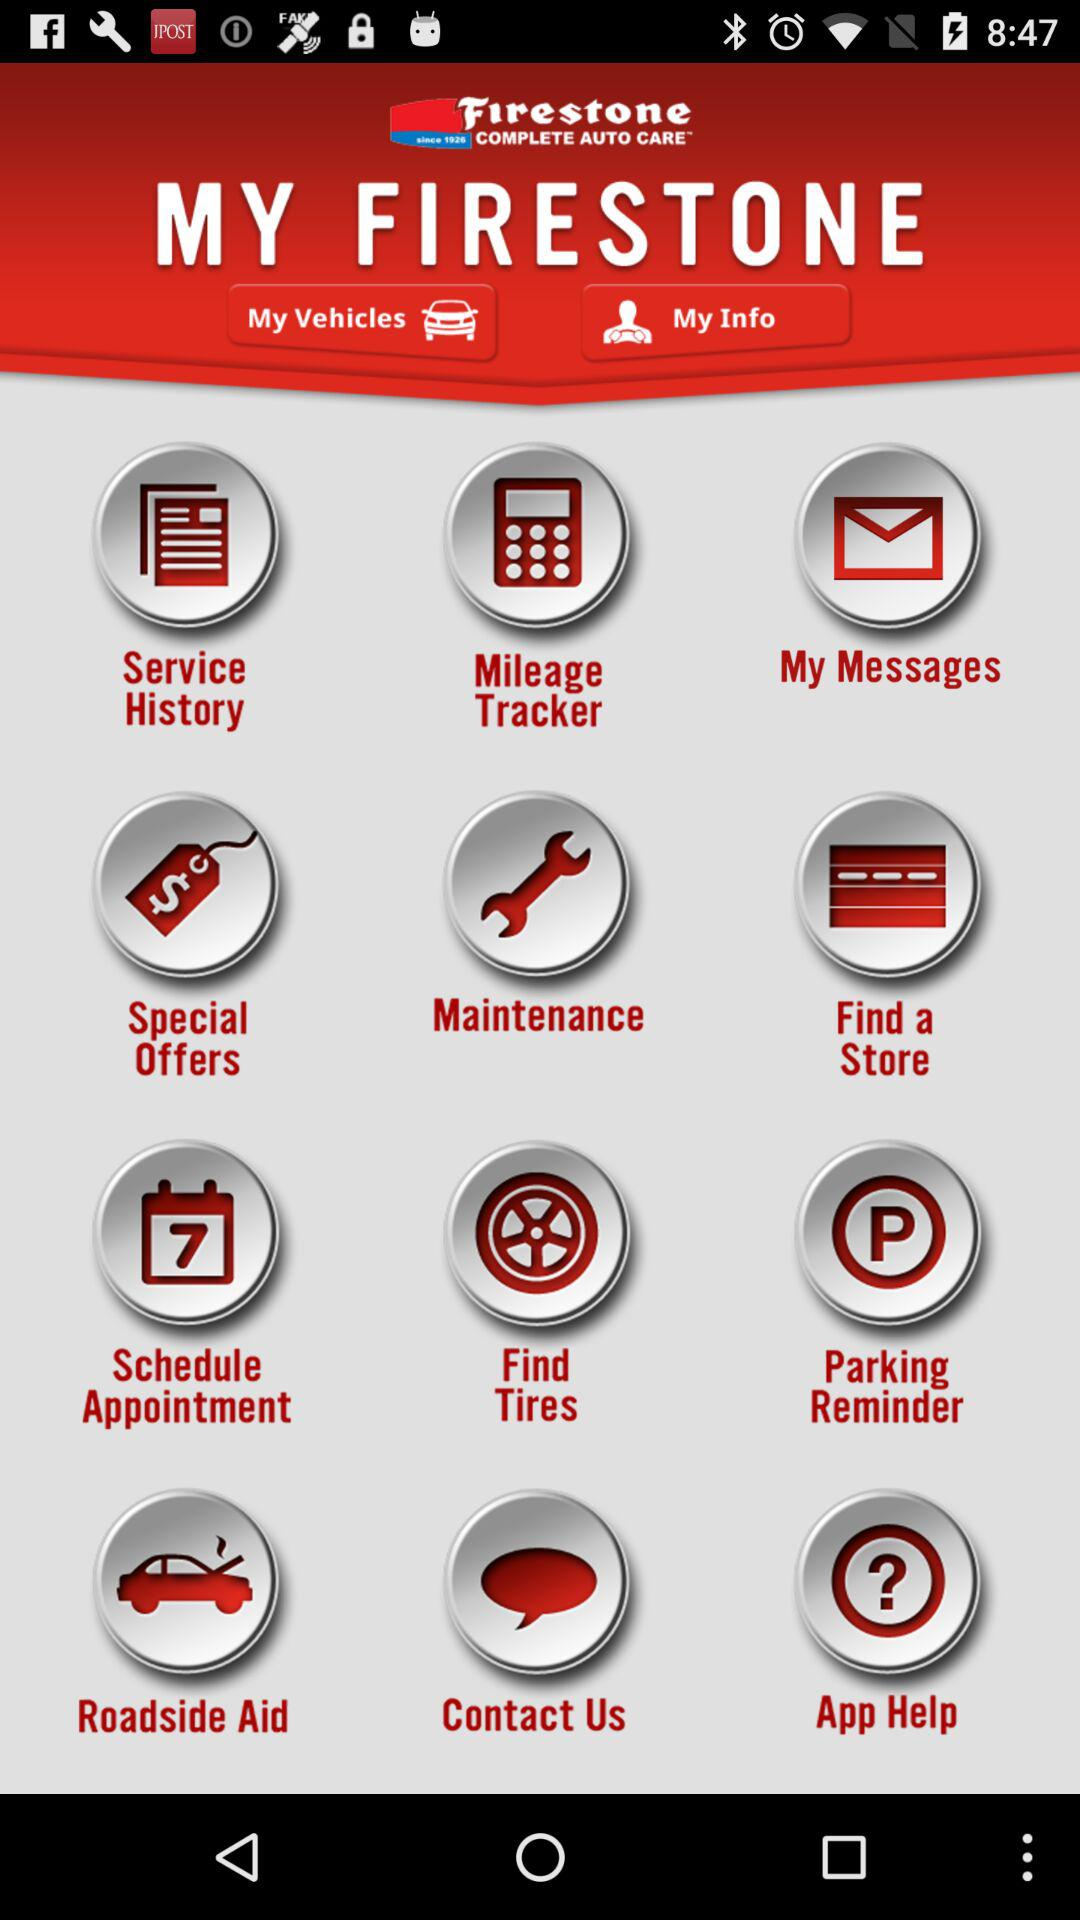What is the name of the application? The application name is "MY FIRESTONE". 